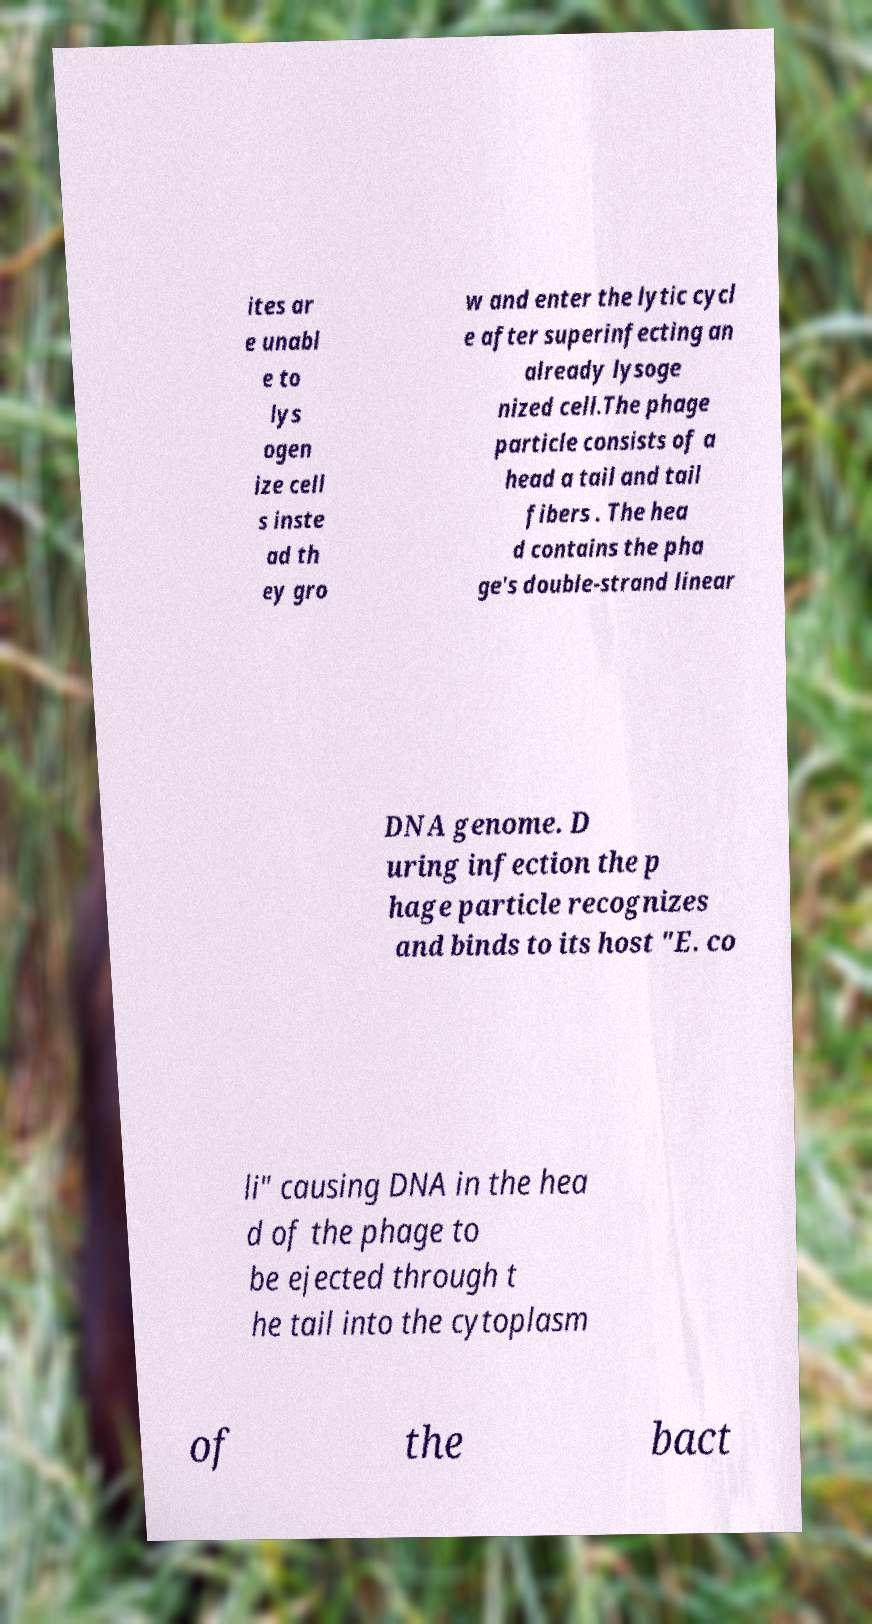Could you extract and type out the text from this image? ites ar e unabl e to lys ogen ize cell s inste ad th ey gro w and enter the lytic cycl e after superinfecting an already lysoge nized cell.The phage particle consists of a head a tail and tail fibers . The hea d contains the pha ge's double-strand linear DNA genome. D uring infection the p hage particle recognizes and binds to its host "E. co li" causing DNA in the hea d of the phage to be ejected through t he tail into the cytoplasm of the bact 